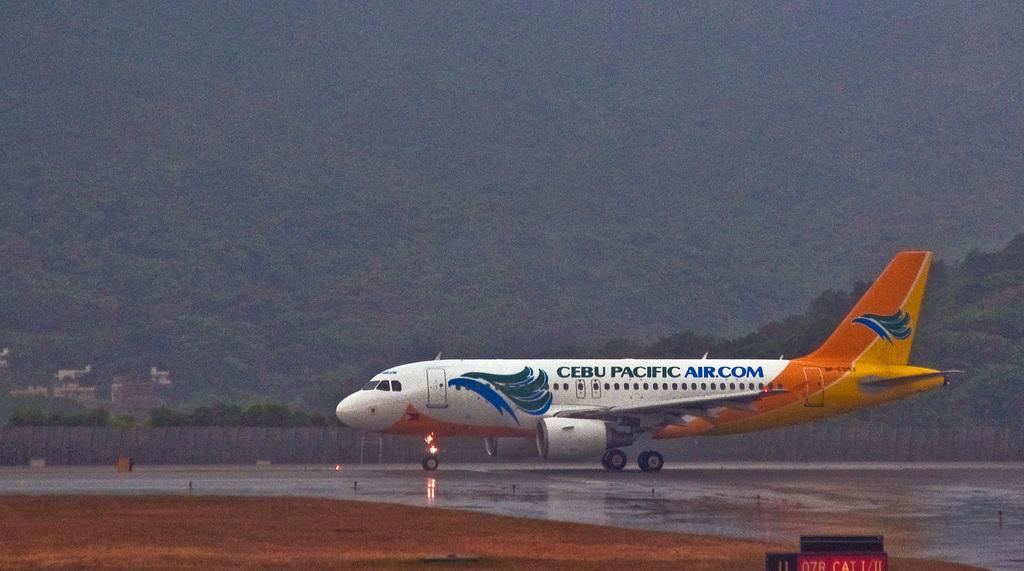What airline is this?
Provide a short and direct response. Cebu pacific air. 